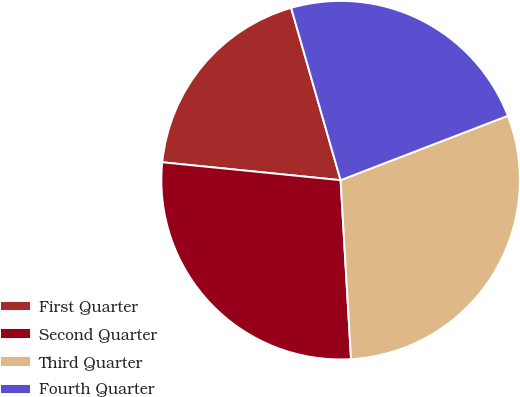<chart> <loc_0><loc_0><loc_500><loc_500><pie_chart><fcel>First Quarter<fcel>Second Quarter<fcel>Third Quarter<fcel>Fourth Quarter<nl><fcel>18.96%<fcel>27.52%<fcel>29.92%<fcel>23.6%<nl></chart> 